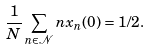<formula> <loc_0><loc_0><loc_500><loc_500>\frac { 1 } { N } \sum _ { n \in \mathcal { N } } n x _ { n } ( 0 ) = 1 / 2 .</formula> 